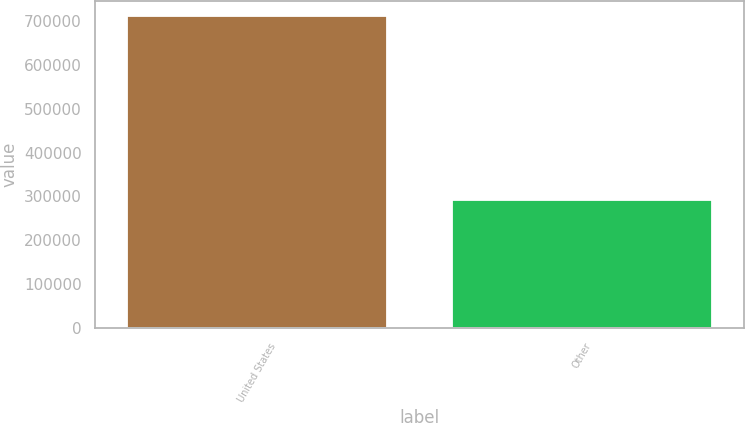Convert chart to OTSL. <chart><loc_0><loc_0><loc_500><loc_500><bar_chart><fcel>United States<fcel>Other<nl><fcel>710614<fcel>291731<nl></chart> 